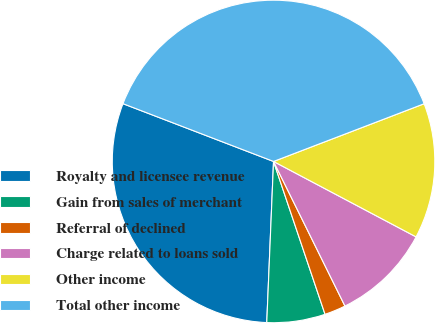Convert chart. <chart><loc_0><loc_0><loc_500><loc_500><pie_chart><fcel>Royalty and licensee revenue<fcel>Gain from sales of merchant<fcel>Referral of declined<fcel>Charge related to loans sold<fcel>Other income<fcel>Total other income<nl><fcel>30.16%<fcel>5.84%<fcel>2.13%<fcel>9.95%<fcel>13.57%<fcel>38.34%<nl></chart> 